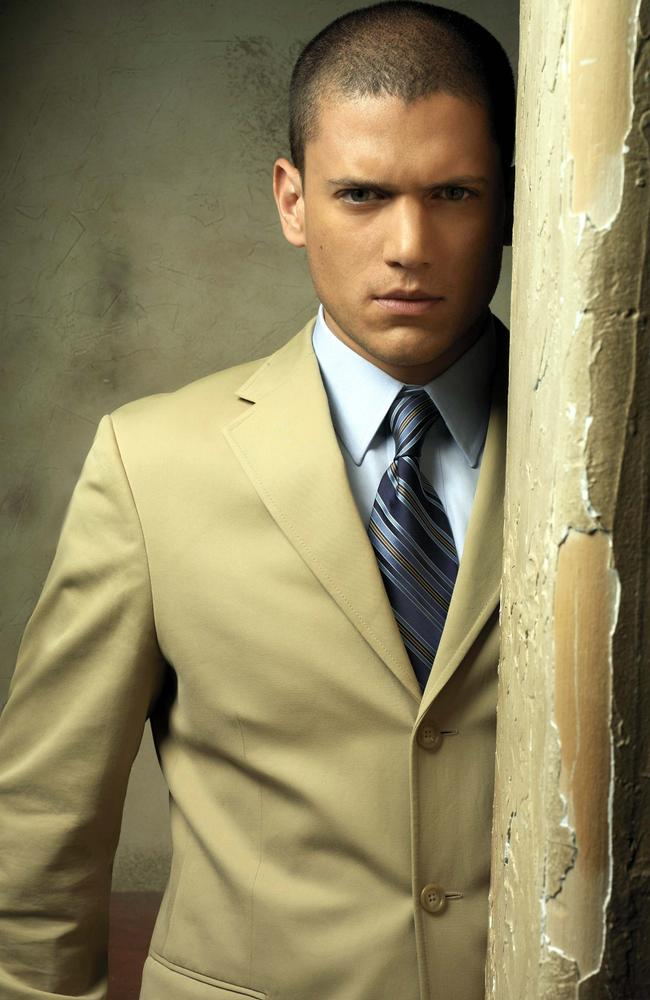What do you think the person in the image is thinking about? The person's intense and direct gaze into the camera, combined with their serious expression, suggests that they might be deep in thought, possibly reflecting on a significant event or contemplating a challenging decision. 